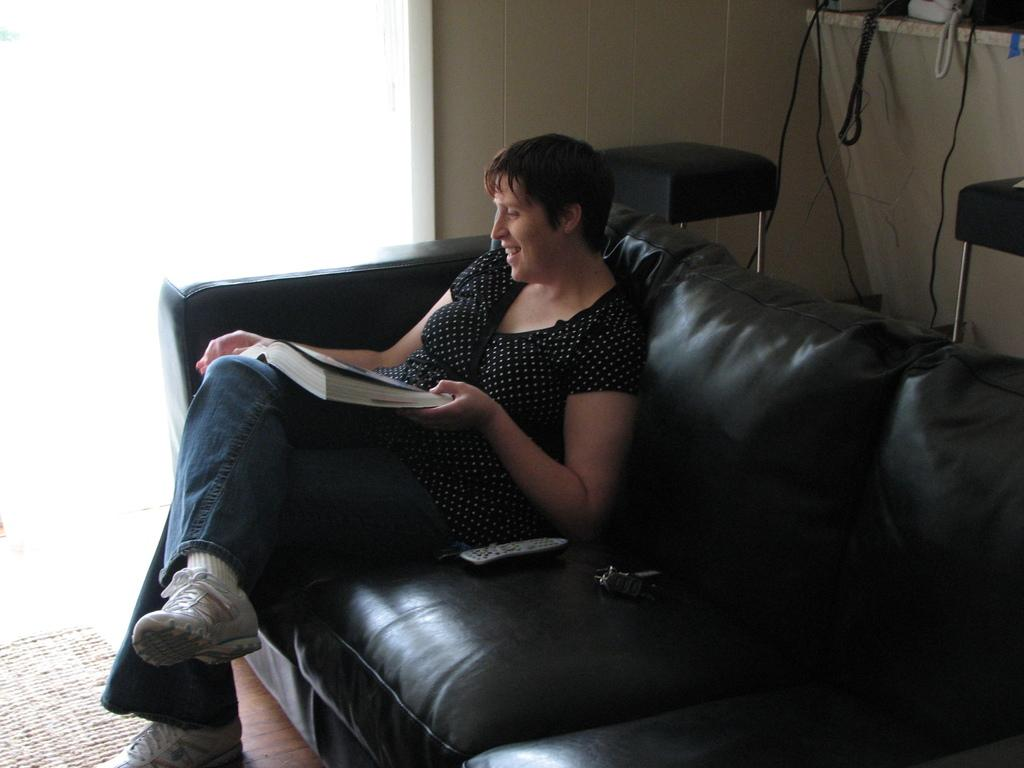What is the woman in the image doing? The woman is sitting on a couch in the image. What is the woman holding in the image? The woman is holding a book. What can be seen in the top right side of the image? There is a wall and two chairs in the top right side of the image. Are there any other objects visible in the image? Yes, there are some wires visible in the image. What type of crow can be seen sitting on the brick in the image? There is no crow or brick present in the image. What calculations can be seen being performed on the calculator in the image? There is no calculator present in the image. 